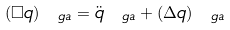<formula> <loc_0><loc_0><loc_500><loc_500>( \Box q ) _ { \ g a } = \ddot { q } _ { \ g a } + ( \Delta q ) _ { \ g a }</formula> 